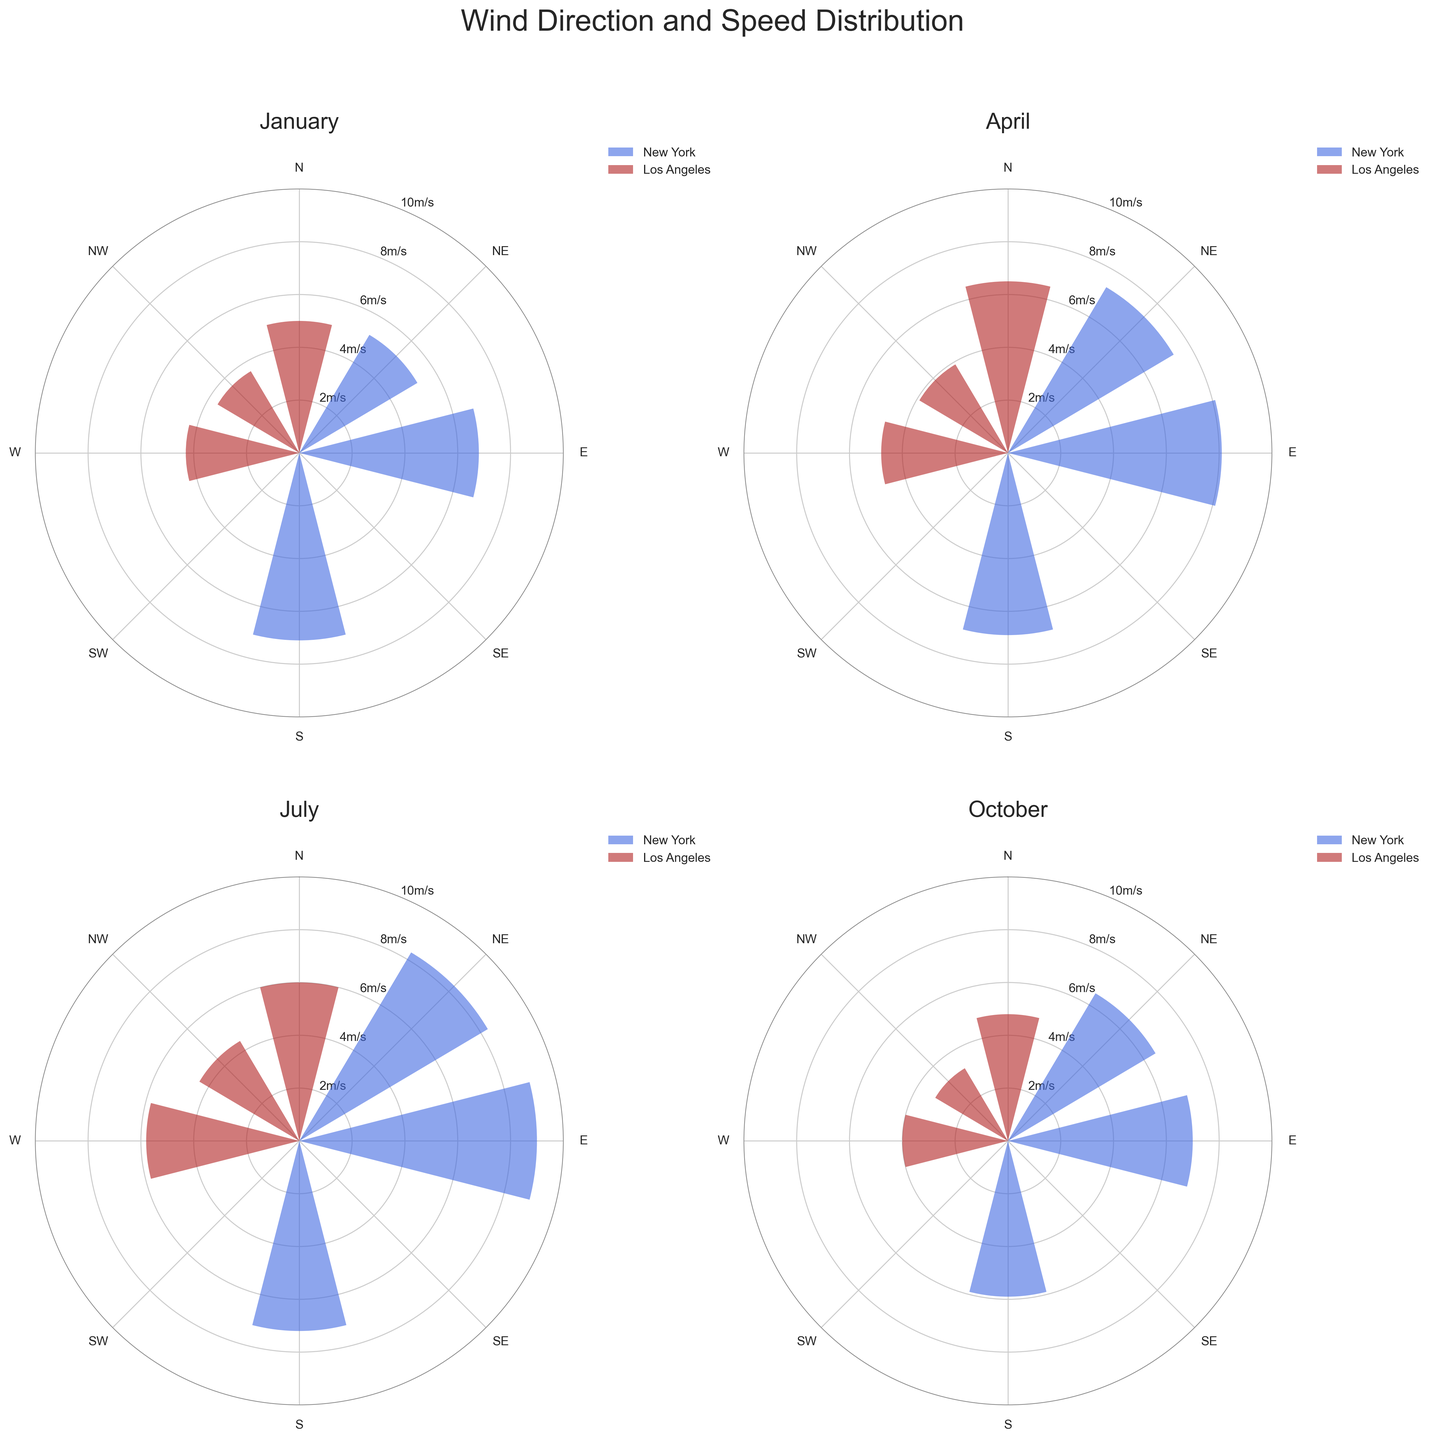What is the title of the figure? The figure’s title is displayed at the top of the overall plot, serving as the main heading for the visualization.
Answer: Wind Direction and Speed Distribution During which month does New York have the highest wind speed? In each subplot representing different months, examine the bars for New York and identify the month where the bar reaches the highest level on the radial axis.
Answer: July Which location generally has higher wind speeds in January? Compare the length of the bars for each location in the January subplot. New York bars reach higher radial values compared to Los Angeles bars.
Answer: New York How does the wind speed distribution in Los Angeles change from January to July? Look at the bars for Los Angeles in both January and July subplots. In January, the speeds are generally lower (highest around 5.0 m/s), while in July, the speeds reach up to 6.0 m/s.
Answer: Increases What is the wind speed in New York at a 45-degree direction in April? Locate the 45-degree direction in the April subplot for New York and observe the corresponding bar's length on the radial axis.
Answer: 7.3 m/s Which direction sees the highest wind speed in Los Angeles in October? Examine the October subplot for Los Angeles and find the direction with the longest bar.
Answer: 0 degrees (North) Is the wind speed distribution pattern in New York similar in January and October? Compare the January and October subplots for New York, noting the number and magnitude of bars. Both months show variable speeds but January has slightly higher values and a more uniform distribution.
Answer: No Which month has the most uniform wind distribution in New York? Look at all the New York subplots and compare the uniformity of bar lengths across directions. April and October show more uniform distribution than July and January.
Answer: April or October How does the prevailing wind direction in New York change over the months? Analyze the direction with the highest wind speeds across all months for New York. In January the strongest is 180, in April and July 90, and in October 90.
Answer: Changes from 180 (S) to 90 (E) Compare the wind speeds at 315 degrees in Los Angeles between April and October. Check the bars at 315 degrees in both Los Angeles April and October subplots. In April, the value is 3.9 m/s. In October, it is lower at 3.2 m/s.
Answer: Higher in April 